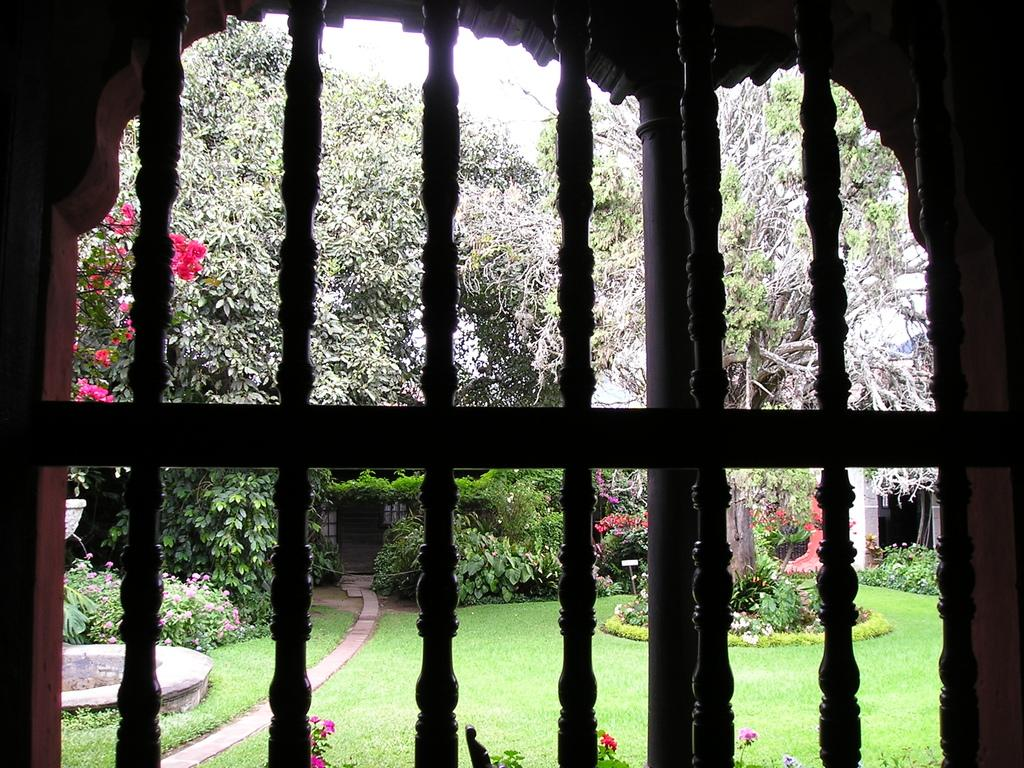What can be seen through the window in the image? Many trees and green grass are visible through the window in the image. Are there any other objects or features visible in the image besides the window? Yes, there are flowers at the bottom of the image. How does the beggar in the image draw attention to themselves? There is no beggar present in the image. 